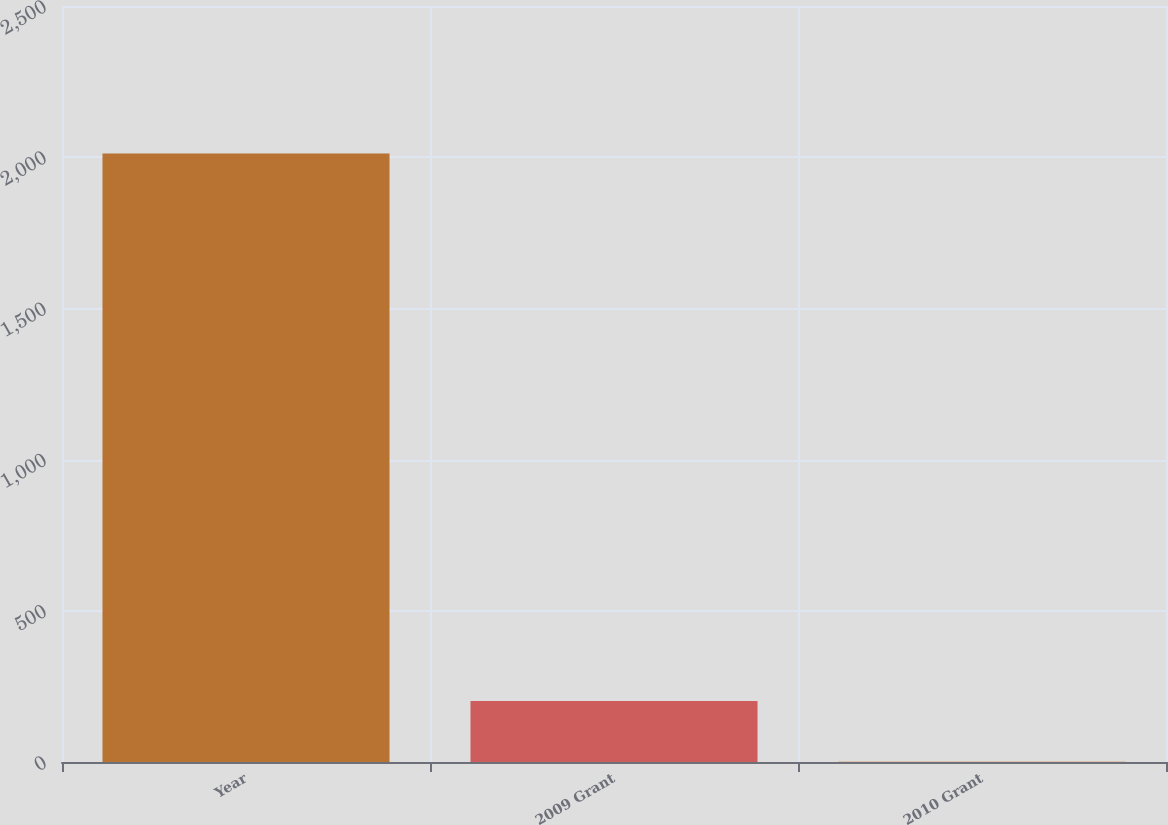Convert chart. <chart><loc_0><loc_0><loc_500><loc_500><bar_chart><fcel>Year<fcel>2009 Grant<fcel>2010 Grant<nl><fcel>2012<fcel>201.74<fcel>0.6<nl></chart> 